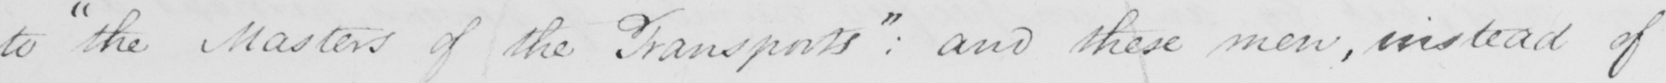Please transcribe the handwritten text in this image. to  " the Masters of the Transports "  :  and these men , instead of 